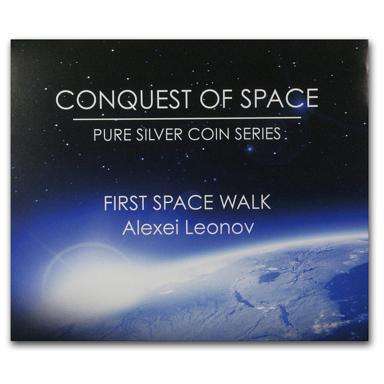Can you tell me more about the significance of the first spacewalk? Certainly! The first spacewalk, officially known as an Extravehicular Activity (EVA), marked a monumental step for human spaceflight. Alexei Leonov's 12-minute foray into the vacuum of space demonstrated that humans could survive and perform tasks outside the protective shell of a spacecraft, paving the way for future EVA-related missions, including satellite repairs, International Space Station (ISS) construction, and advancing the feasibility of exploring other celestial bodies. 